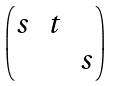<formula> <loc_0><loc_0><loc_500><loc_500>\begin{pmatrix} s & t & \\ & & s \end{pmatrix}</formula> 